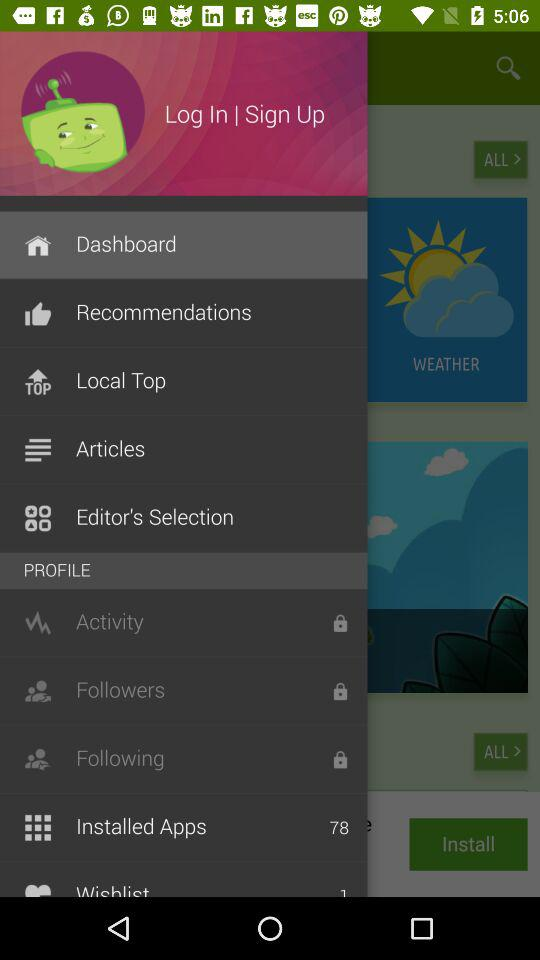How many followers are there?
When the provided information is insufficient, respond with <no answer>. <no answer> 